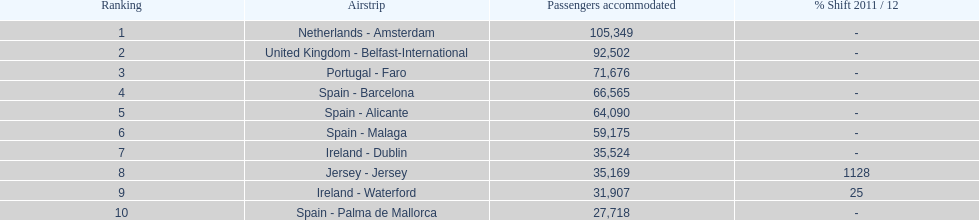How many passengers were handled in an airport in spain? 217,548. 